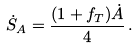<formula> <loc_0><loc_0><loc_500><loc_500>\dot { S } _ { A } = \frac { ( 1 + f _ { T } ) \dot { A } } { 4 } \, .</formula> 